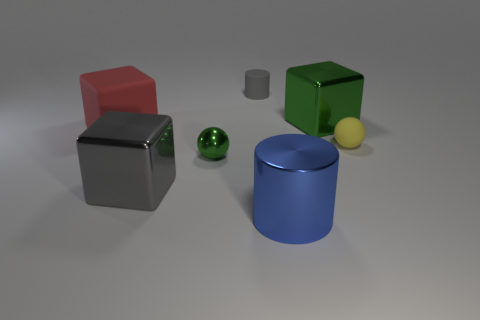Add 2 tiny cylinders. How many objects exist? 9 Subtract all cylinders. How many objects are left? 5 Subtract all large purple cubes. Subtract all blue objects. How many objects are left? 6 Add 1 matte cylinders. How many matte cylinders are left? 2 Add 6 tiny shiny objects. How many tiny shiny objects exist? 7 Subtract 1 red cubes. How many objects are left? 6 